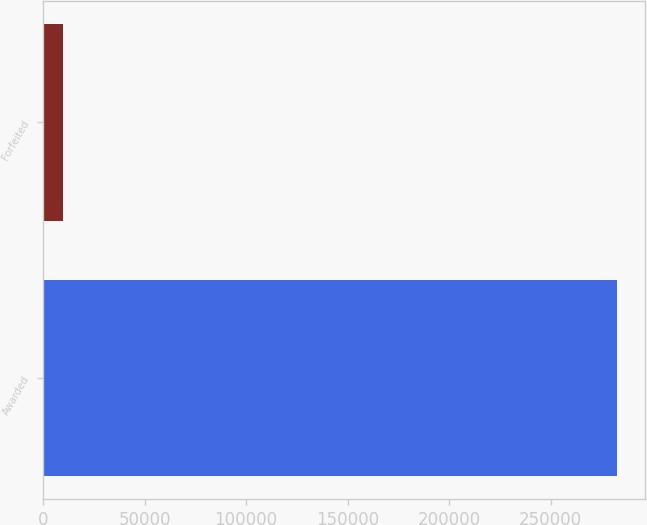Convert chart to OTSL. <chart><loc_0><loc_0><loc_500><loc_500><bar_chart><fcel>Awarded<fcel>Forfeited<nl><fcel>282423<fcel>10000<nl></chart> 